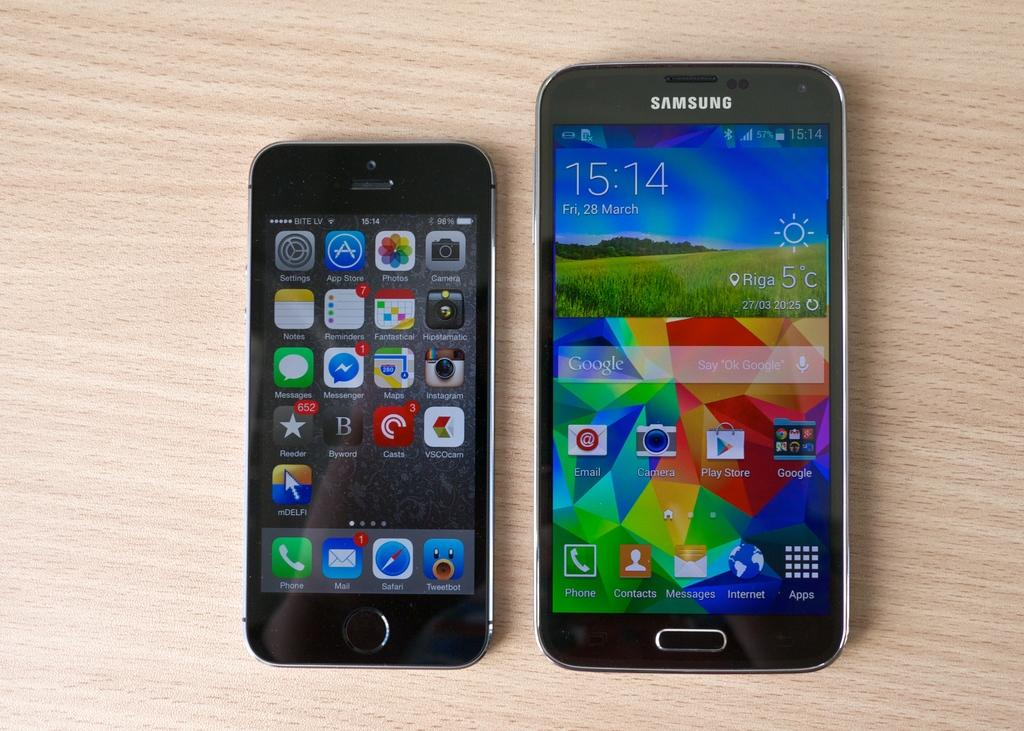Provide a one-sentence caption for the provided image. A Samsung phone sits next to an iPhone on a table. 